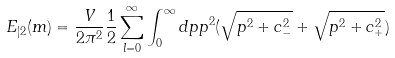<formula> <loc_0><loc_0><loc_500><loc_500>E _ { | 2 } ( m ) = \frac { V } { 2 \pi ^ { 2 } } \frac { 1 } { 2 } \sum _ { l = 0 } ^ { \infty } \int _ { 0 } ^ { \infty } d p p ^ { 2 } ( \sqrt { p ^ { 2 } + c _ { - } ^ { 2 } } + \sqrt { p ^ { 2 } + c _ { + } ^ { 2 } } )</formula> 